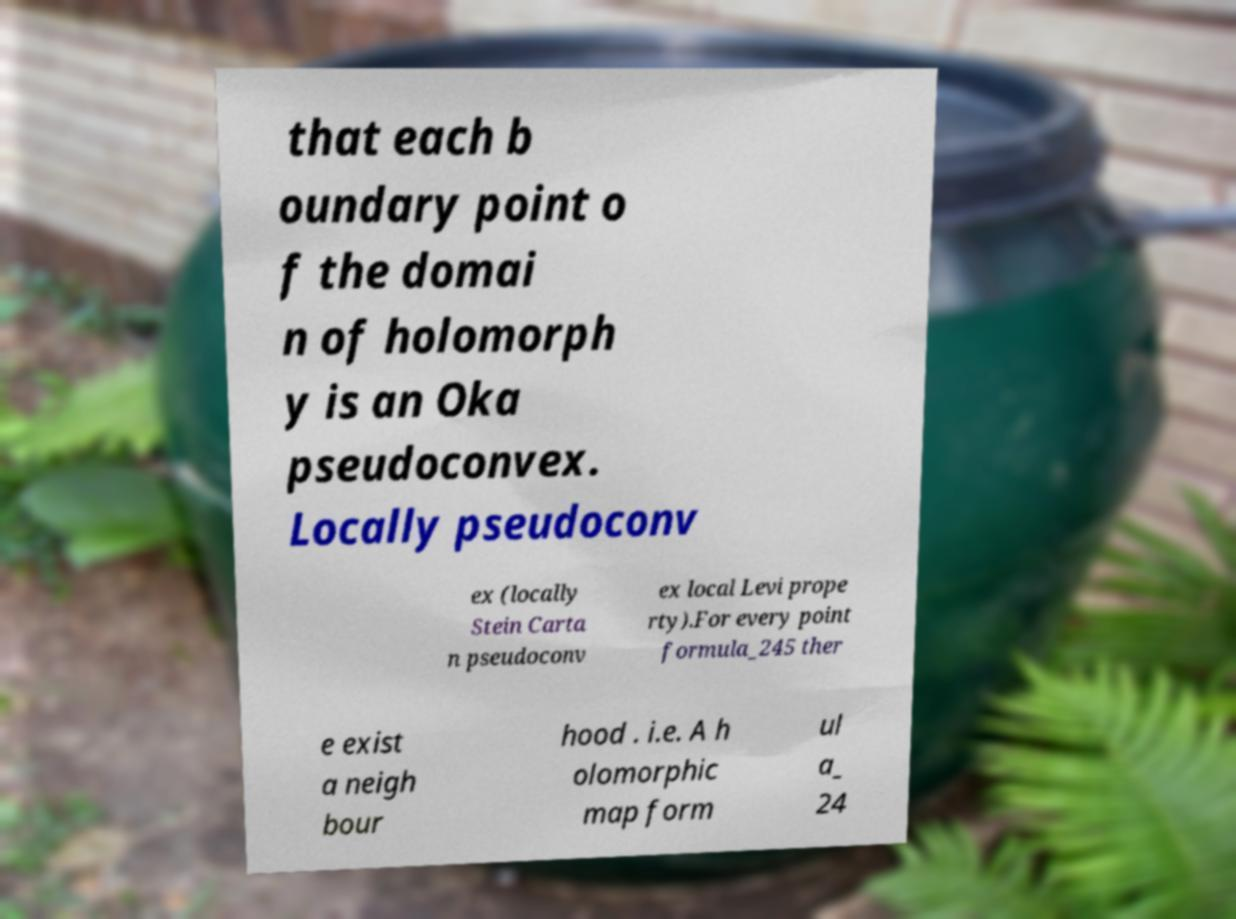I need the written content from this picture converted into text. Can you do that? that each b oundary point o f the domai n of holomorph y is an Oka pseudoconvex. Locally pseudoconv ex (locally Stein Carta n pseudoconv ex local Levi prope rty).For every point formula_245 ther e exist a neigh bour hood . i.e. A h olomorphic map form ul a_ 24 